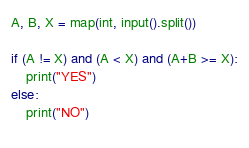Convert code to text. <code><loc_0><loc_0><loc_500><loc_500><_Python_>A, B, X = map(int, input().split())

if (A != X) and (A < X) and (A+B >= X):
    print("YES")
else:
    print("NO")
    </code> 